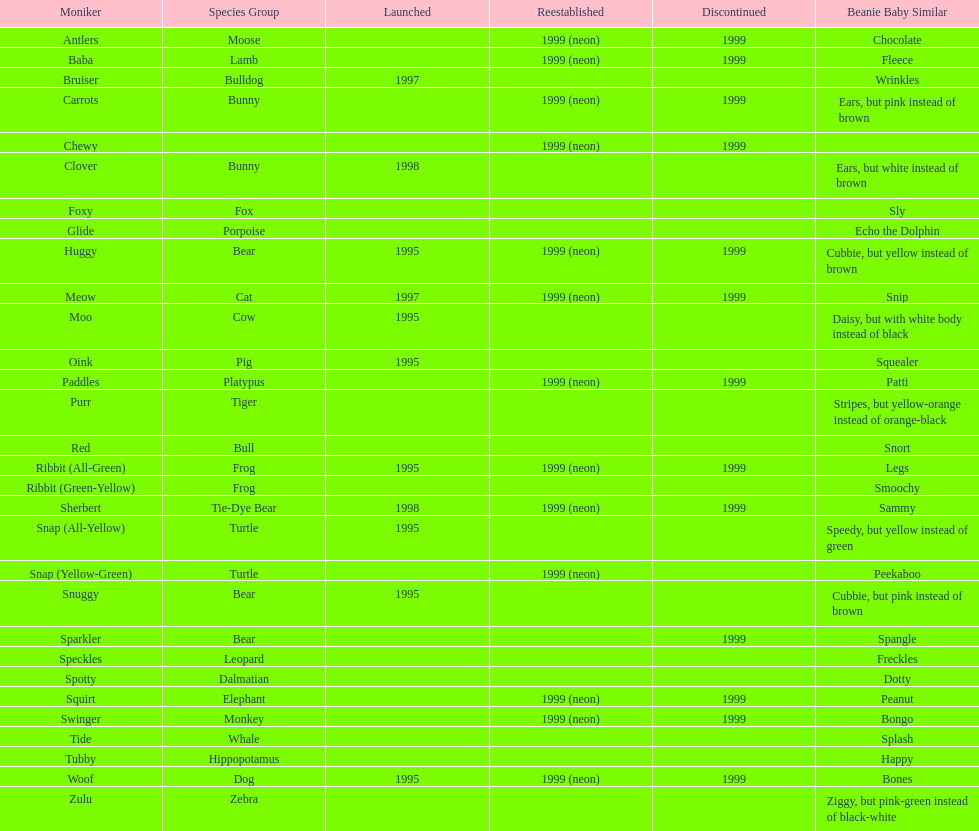What is the name of the pillow pal listed after clover? Foxy. Would you be able to parse every entry in this table? {'header': ['Moniker', 'Species Group', 'Launched', 'Reestablished', 'Discontinued', 'Beanie Baby Similar'], 'rows': [['Antlers', 'Moose', '', '1999 (neon)', '1999', 'Chocolate'], ['Baba', 'Lamb', '', '1999 (neon)', '1999', 'Fleece'], ['Bruiser', 'Bulldog', '1997', '', '', 'Wrinkles'], ['Carrots', 'Bunny', '', '1999 (neon)', '1999', 'Ears, but pink instead of brown'], ['Chewy', '', '', '1999 (neon)', '1999', ''], ['Clover', 'Bunny', '1998', '', '', 'Ears, but white instead of brown'], ['Foxy', 'Fox', '', '', '', 'Sly'], ['Glide', 'Porpoise', '', '', '', 'Echo the Dolphin'], ['Huggy', 'Bear', '1995', '1999 (neon)', '1999', 'Cubbie, but yellow instead of brown'], ['Meow', 'Cat', '1997', '1999 (neon)', '1999', 'Snip'], ['Moo', 'Cow', '1995', '', '', 'Daisy, but with white body instead of black'], ['Oink', 'Pig', '1995', '', '', 'Squealer'], ['Paddles', 'Platypus', '', '1999 (neon)', '1999', 'Patti'], ['Purr', 'Tiger', '', '', '', 'Stripes, but yellow-orange instead of orange-black'], ['Red', 'Bull', '', '', '', 'Snort'], ['Ribbit (All-Green)', 'Frog', '1995', '1999 (neon)', '1999', 'Legs'], ['Ribbit (Green-Yellow)', 'Frog', '', '', '', 'Smoochy'], ['Sherbert', 'Tie-Dye Bear', '1998', '1999 (neon)', '1999', 'Sammy'], ['Snap (All-Yellow)', 'Turtle', '1995', '', '', 'Speedy, but yellow instead of green'], ['Snap (Yellow-Green)', 'Turtle', '', '1999 (neon)', '', 'Peekaboo'], ['Snuggy', 'Bear', '1995', '', '', 'Cubbie, but pink instead of brown'], ['Sparkler', 'Bear', '', '', '1999', 'Spangle'], ['Speckles', 'Leopard', '', '', '', 'Freckles'], ['Spotty', 'Dalmatian', '', '', '', 'Dotty'], ['Squirt', 'Elephant', '', '1999 (neon)', '1999', 'Peanut'], ['Swinger', 'Monkey', '', '1999 (neon)', '1999', 'Bongo'], ['Tide', 'Whale', '', '', '', 'Splash'], ['Tubby', 'Hippopotamus', '', '', '', 'Happy'], ['Woof', 'Dog', '1995', '1999 (neon)', '1999', 'Bones'], ['Zulu', 'Zebra', '', '', '', 'Ziggy, but pink-green instead of black-white']]} 